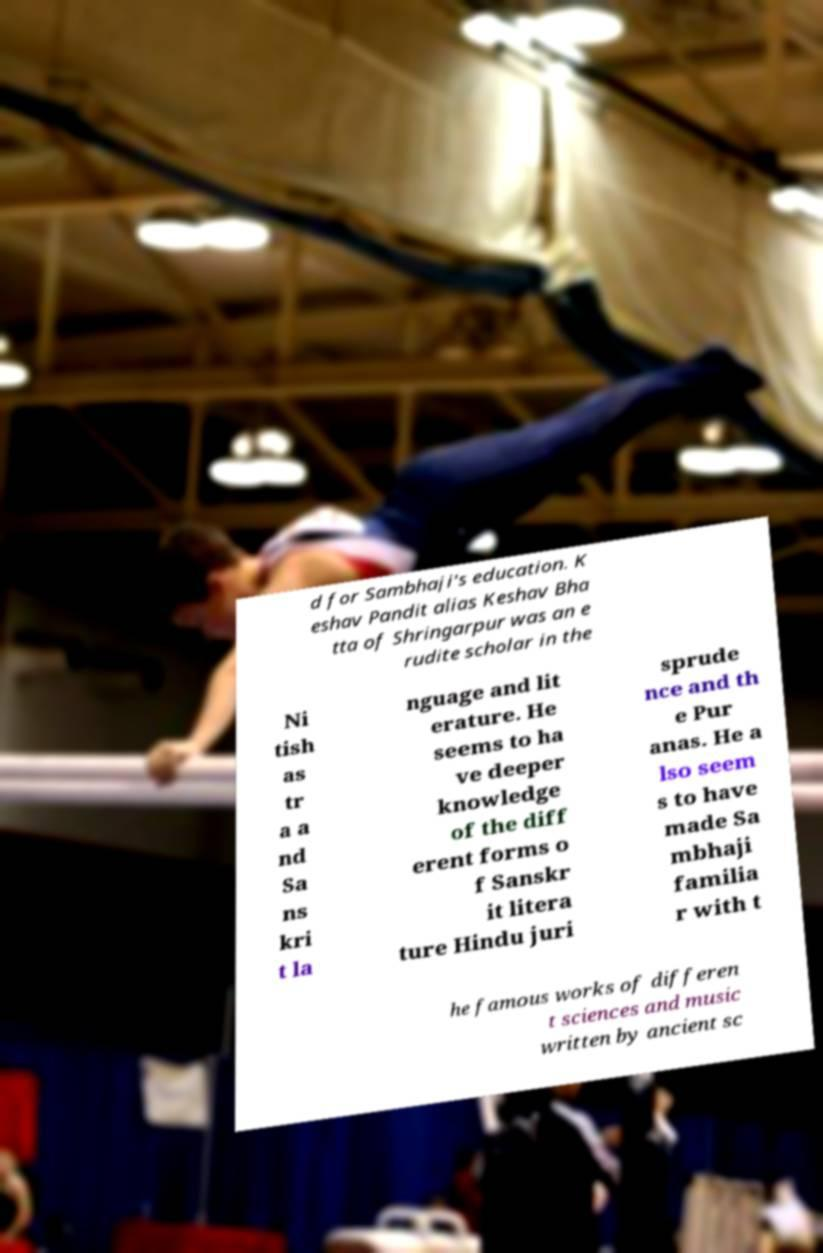Please identify and transcribe the text found in this image. d for Sambhaji's education. K eshav Pandit alias Keshav Bha tta of Shringarpur was an e rudite scholar in the Ni tish as tr a a nd Sa ns kri t la nguage and lit erature. He seems to ha ve deeper knowledge of the diff erent forms o f Sanskr it litera ture Hindu juri sprude nce and th e Pur anas. He a lso seem s to have made Sa mbhaji familia r with t he famous works of differen t sciences and music written by ancient sc 